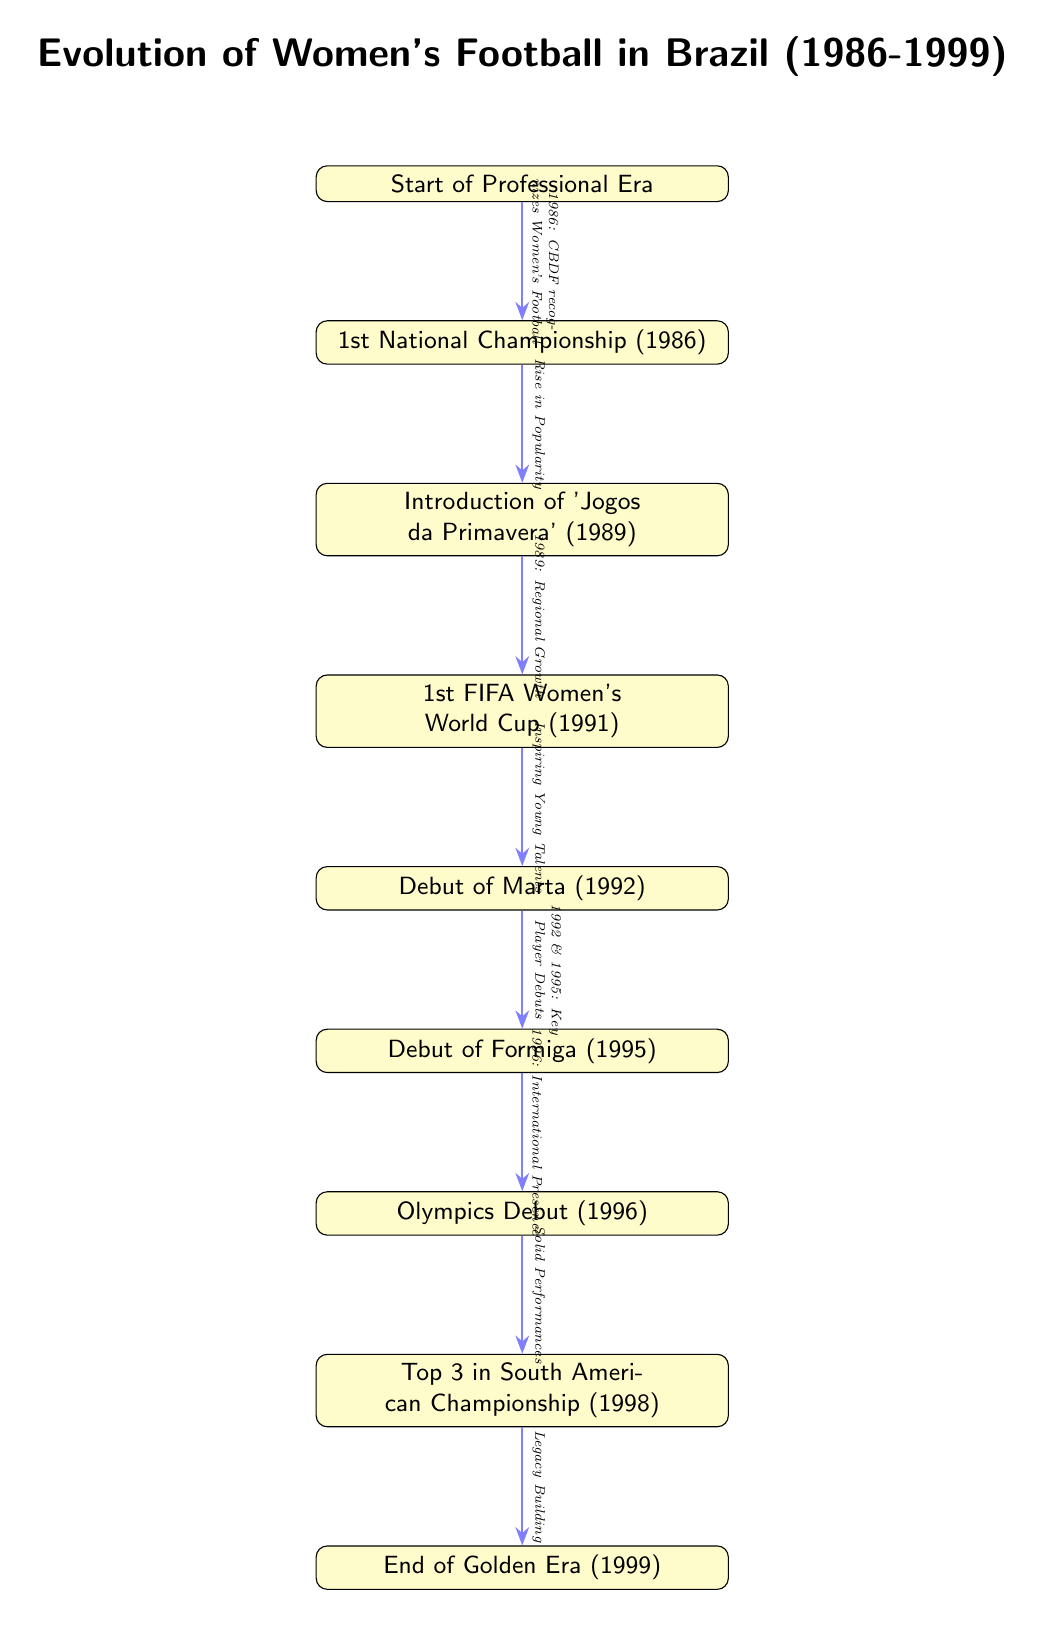What event marked the beginning of professional women's football in Brazil? The diagram indicates that the start of the professional era is represented by the 'Start of Professional Era' node, which leads to the '1st National Championship (1986)' node.
Answer: Start of Professional Era What year did the 1st National Championship take place? The '1st National Championship' is noted in the diagram as occurring in 1986, directly beneath the 'Start of Professional Era' node.
Answer: 1986 Which tournament was introduced in 1989? The diagram states that the 'Jogos da Primavera' was introduced in 1989, as indicated in the corresponding node below the '1st National Championship (1986)' node.
Answer: Jogos da Primavera What significant event occurred in 1996 in Brazilian women's football? According to the diagram, the 'Olympics Debut' therefore indicating that Brazilian women's football participated in the Olympics for the first time in 1996, is shown as a key milestone.
Answer: Olympics Debut How many key players debuted in the timeline? The diagram highlights two key player debuts: Marta in 1992 and Formiga in 1995, as indicated in their respective nodes.
Answer: 2 What was the top achievement of the Brazilian women's football team in 1998? The diagram notes that in 1998, the team reached 'Top 3 in South American Championship', illustrating a notable accomplishment in that year.
Answer: Top 3 in South American Championship What major milestone did the Brazilian women's football team achieve in 1991? The diagram identifies the '1st FIFA Women's World Cup (1991)' as a major event in that year, indicating it was the team's first participation in this global tournament.
Answer: 1st FIFA Women's World Cup What does the arrow labeled "Legacy Building" indicate in the diagram? The arrow indicates the transition from 'Top 3 in South American Championship (1998)' to 'End of Golden Era (1999)', suggesting that achieving this standing contributed to establishing a legacy.
Answer: Legacy Building How did the introduction of 'Jogos da Primavera' (1989) affect women's football? The diagram states that this introduction resulted in a 'Rise in Popularity', illustrating its positive impact on the sport in Brazil.
Answer: Rise in Popularity 